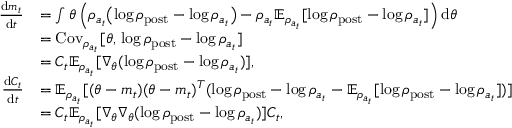<formula> <loc_0><loc_0><loc_500><loc_500>\begin{array} { r l } { \frac { d m _ { t } } { d t } } & { = \int \theta \left ( \rho _ { a _ { t } } \left ( \log \rho _ { p o s t } - \log \rho _ { a _ { t } } \right ) - \rho _ { a _ { t } } \mathbb { E } _ { \rho _ { a _ { t } } } [ \log \rho _ { p o s t } - \log \rho _ { a _ { t } } ] \right ) d \theta } \\ & { = C o v _ { \rho _ { a _ { t } } } [ \theta , \, \log \rho _ { p o s t } - \log \rho _ { a _ { t } } ] } \\ & { = C _ { t } \mathbb { E } _ { \rho _ { a _ { t } } } [ \nabla _ { \theta } ( \log \rho _ { p o s t } - \log \rho _ { a _ { t } } ) ] , } \\ { \frac { d C _ { t } } { d t } } & { = \mathbb { E } _ { \rho _ { a _ { t } } } [ ( \theta - m _ { t } ) ( \theta - m _ { t } ) ^ { T } ( \log \rho _ { p o s t } - \log \rho _ { a _ { t } } - \mathbb { E } _ { \rho _ { a _ { t } } } [ \log \rho _ { p o s t } - \log \rho _ { a _ { t } } ] ) ] } \\ & { = C _ { t } \mathbb { E } _ { \rho _ { a _ { t } } } [ \nabla _ { \theta } \nabla _ { \theta } ( \log \rho _ { p o s t } - \log \rho _ { a _ { t } } ) ] C _ { t } , } \end{array}</formula> 